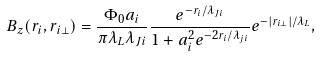<formula> <loc_0><loc_0><loc_500><loc_500>B _ { z } ( r _ { i } , r _ { i \bot } ) = \frac { \Phi _ { 0 } a _ { i } } { \pi \lambda _ { L } \lambda _ { J i } } \frac { e ^ { - r _ { i } / \lambda _ { J i } } } { 1 + a _ { i } ^ { 2 } e ^ { - 2 r _ { i } / \lambda _ { j i } } } e ^ { - | r _ { i \bot } | / \lambda _ { L } } ,</formula> 